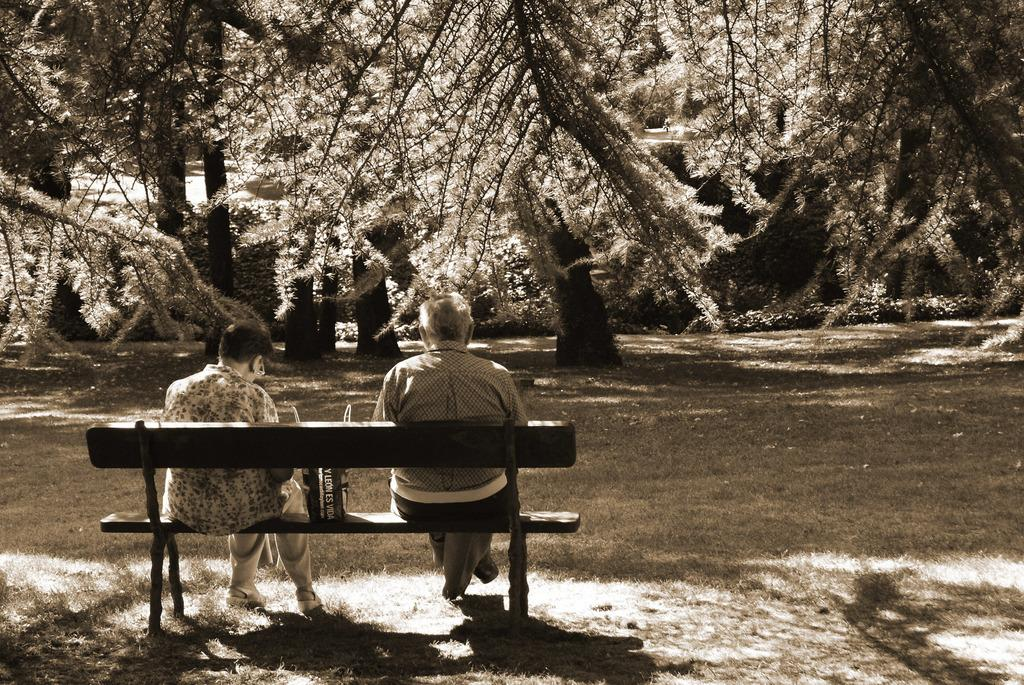How many people are sitting on the bench in the image? There are two persons sitting on a bench in the image. What else is on the bench besides the people? There is a bag on the bench. What type of vegetation can be seen in the image? There are plants and trees in the image. What is the color scheme of the image? The image is in black and white mode. What type of park can be seen in the image? There is no park visible in the image. What is the relationship between the two persons sitting on the bench? The relationship between the two persons sitting on the bench is not mentioned in the image. How many flies can be seen in the image? There are no flies present in the image. 